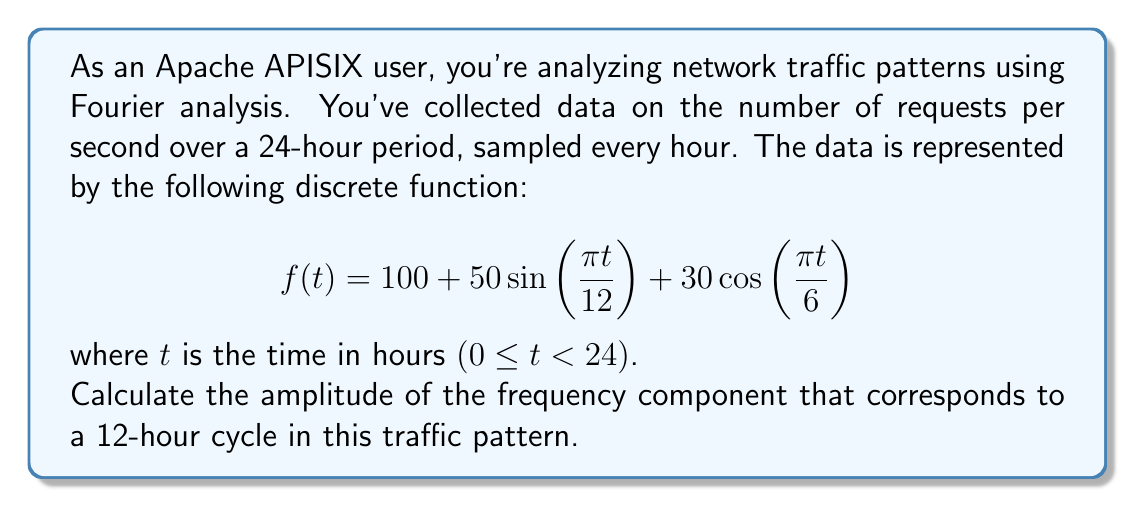What is the answer to this math problem? To solve this problem, we need to analyze the given function using Fourier analysis principles:

1) The given function is already in the form of a Fourier series:

   $$f(t) = A_0 + A_1\sin(\omega_1 t) + B_1\cos(\omega_2 t)$$

2) We can identify the components:
   - $A_0 = 100$ (constant term)
   - $A_1 = 50$, $\omega_1 = \frac{\pi}{12}$
   - $B_1 = 30$, $\omega_2 = \frac{\pi}{6}$

3) The frequency of a component is related to its angular frequency $\omega$ by the formula:
   $$f = \frac{\omega}{2\pi}$$

4) For the 12-hour cycle, we're interested in the component with $\omega = \frac{\pi}{12}$:
   $$f = \frac{\pi/12}{2\pi} = \frac{1}{24} \text{ cycles per hour} = \frac{1}{12} \text{ cycles per 12 hours}$$

5) This corresponds to the sine term: $50\sin\left(\frac{\pi t}{12}\right)$

6) The amplitude of this component is 50.

Therefore, the amplitude of the 12-hour cycle component in the traffic pattern is 50 requests per second.
Answer: 50 requests per second 